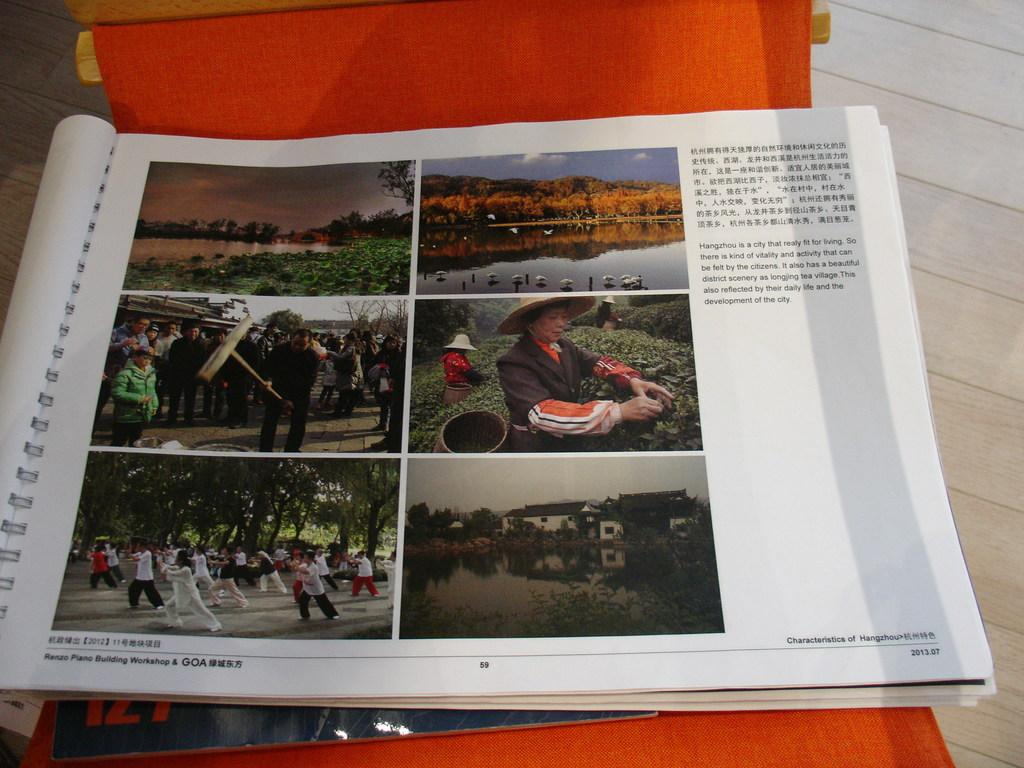What type of furniture is visible in the image? There is an object that looks like a chair in the image. Where is the chair located? The chair is on the floor. What is on top of the chair? There is a book on the chair. Can you describe the book? The book has images and text. How does the chair celebrate the holiday in the image? The chair does not celebrate a holiday in the image; it is simply a piece of furniture on the floor. 